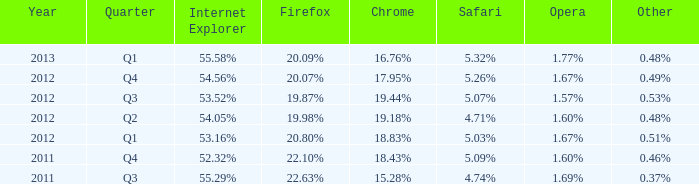What safari has 2012 q4 as the period? 5.26%. 